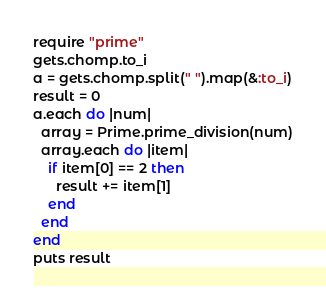Convert code to text. <code><loc_0><loc_0><loc_500><loc_500><_Ruby_>require "prime"
gets.chomp.to_i
a = gets.chomp.split(" ").map(&:to_i)
result = 0
a.each do |num|
  array = Prime.prime_division(num)
  array.each do |item|
    if item[0] == 2 then
      result += item[1]
    end
  end
end
puts result</code> 